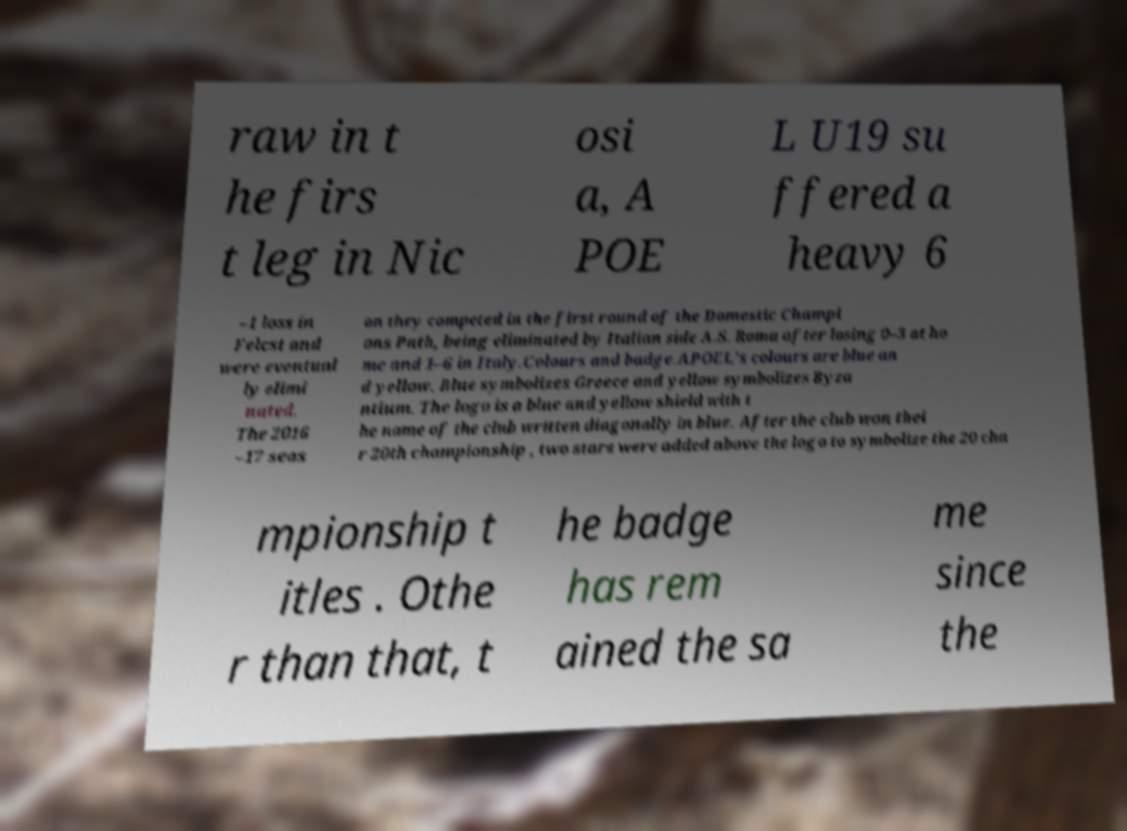Can you read and provide the text displayed in the image?This photo seems to have some interesting text. Can you extract and type it out for me? raw in t he firs t leg in Nic osi a, A POE L U19 su ffered a heavy 6 –1 loss in Felcst and were eventual ly elimi nated. The 2016 –17 seas on they competed in the first round of the Domestic Champi ons Path, being eliminated by Italian side A.S. Roma after losing 0–3 at ho me and 1–6 in Italy.Colours and badge.APOEL's colours are blue an d yellow. Blue symbolizes Greece and yellow symbolizes Byza ntium. The logo is a blue and yellow shield with t he name of the club written diagonally in blue. After the club won thei r 20th championship , two stars were added above the logo to symbolize the 20 cha mpionship t itles . Othe r than that, t he badge has rem ained the sa me since the 